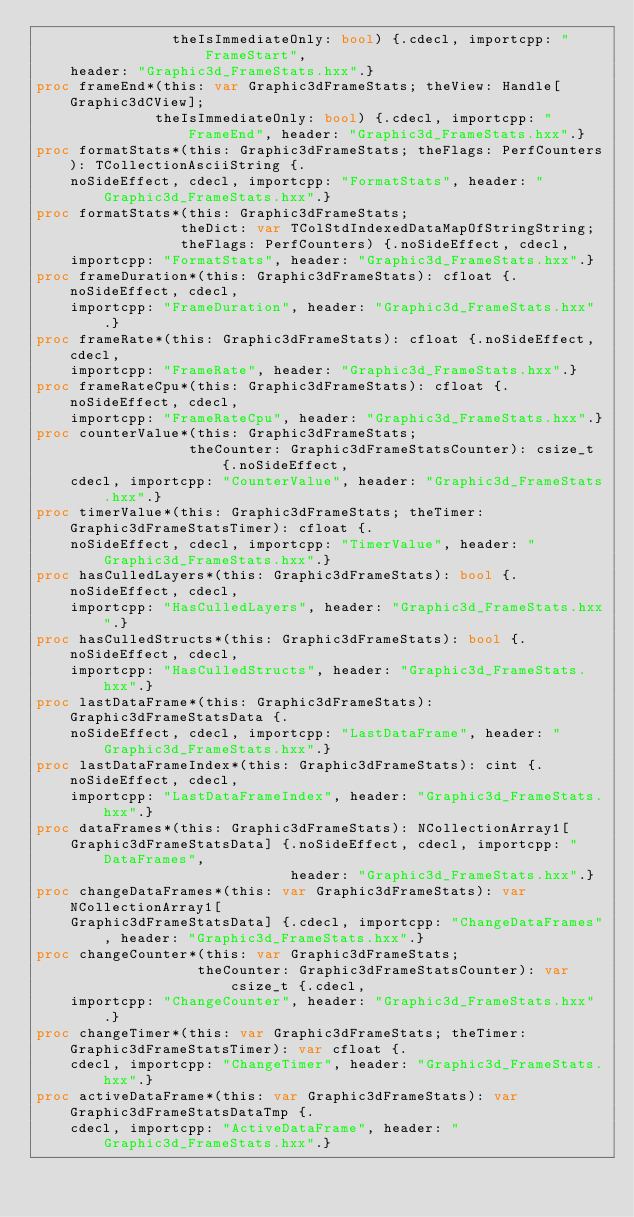<code> <loc_0><loc_0><loc_500><loc_500><_Nim_>                theIsImmediateOnly: bool) {.cdecl, importcpp: "FrameStart",
    header: "Graphic3d_FrameStats.hxx".}
proc frameEnd*(this: var Graphic3dFrameStats; theView: Handle[Graphic3dCView];
              theIsImmediateOnly: bool) {.cdecl, importcpp: "FrameEnd", header: "Graphic3d_FrameStats.hxx".}
proc formatStats*(this: Graphic3dFrameStats; theFlags: PerfCounters): TCollectionAsciiString {.
    noSideEffect, cdecl, importcpp: "FormatStats", header: "Graphic3d_FrameStats.hxx".}
proc formatStats*(this: Graphic3dFrameStats;
                 theDict: var TColStdIndexedDataMapOfStringString;
                 theFlags: PerfCounters) {.noSideEffect, cdecl,
    importcpp: "FormatStats", header: "Graphic3d_FrameStats.hxx".}
proc frameDuration*(this: Graphic3dFrameStats): cfloat {.noSideEffect, cdecl,
    importcpp: "FrameDuration", header: "Graphic3d_FrameStats.hxx".}
proc frameRate*(this: Graphic3dFrameStats): cfloat {.noSideEffect, cdecl,
    importcpp: "FrameRate", header: "Graphic3d_FrameStats.hxx".}
proc frameRateCpu*(this: Graphic3dFrameStats): cfloat {.noSideEffect, cdecl,
    importcpp: "FrameRateCpu", header: "Graphic3d_FrameStats.hxx".}
proc counterValue*(this: Graphic3dFrameStats;
                  theCounter: Graphic3dFrameStatsCounter): csize_t {.noSideEffect,
    cdecl, importcpp: "CounterValue", header: "Graphic3d_FrameStats.hxx".}
proc timerValue*(this: Graphic3dFrameStats; theTimer: Graphic3dFrameStatsTimer): cfloat {.
    noSideEffect, cdecl, importcpp: "TimerValue", header: "Graphic3d_FrameStats.hxx".}
proc hasCulledLayers*(this: Graphic3dFrameStats): bool {.noSideEffect, cdecl,
    importcpp: "HasCulledLayers", header: "Graphic3d_FrameStats.hxx".}
proc hasCulledStructs*(this: Graphic3dFrameStats): bool {.noSideEffect, cdecl,
    importcpp: "HasCulledStructs", header: "Graphic3d_FrameStats.hxx".}
proc lastDataFrame*(this: Graphic3dFrameStats): Graphic3dFrameStatsData {.
    noSideEffect, cdecl, importcpp: "LastDataFrame", header: "Graphic3d_FrameStats.hxx".}
proc lastDataFrameIndex*(this: Graphic3dFrameStats): cint {.noSideEffect, cdecl,
    importcpp: "LastDataFrameIndex", header: "Graphic3d_FrameStats.hxx".}
proc dataFrames*(this: Graphic3dFrameStats): NCollectionArray1[
    Graphic3dFrameStatsData] {.noSideEffect, cdecl, importcpp: "DataFrames",
                              header: "Graphic3d_FrameStats.hxx".}
proc changeDataFrames*(this: var Graphic3dFrameStats): var NCollectionArray1[
    Graphic3dFrameStatsData] {.cdecl, importcpp: "ChangeDataFrames", header: "Graphic3d_FrameStats.hxx".}
proc changeCounter*(this: var Graphic3dFrameStats;
                   theCounter: Graphic3dFrameStatsCounter): var csize_t {.cdecl,
    importcpp: "ChangeCounter", header: "Graphic3d_FrameStats.hxx".}
proc changeTimer*(this: var Graphic3dFrameStats; theTimer: Graphic3dFrameStatsTimer): var cfloat {.
    cdecl, importcpp: "ChangeTimer", header: "Graphic3d_FrameStats.hxx".}
proc activeDataFrame*(this: var Graphic3dFrameStats): var Graphic3dFrameStatsDataTmp {.
    cdecl, importcpp: "ActiveDataFrame", header: "Graphic3d_FrameStats.hxx".}</code> 